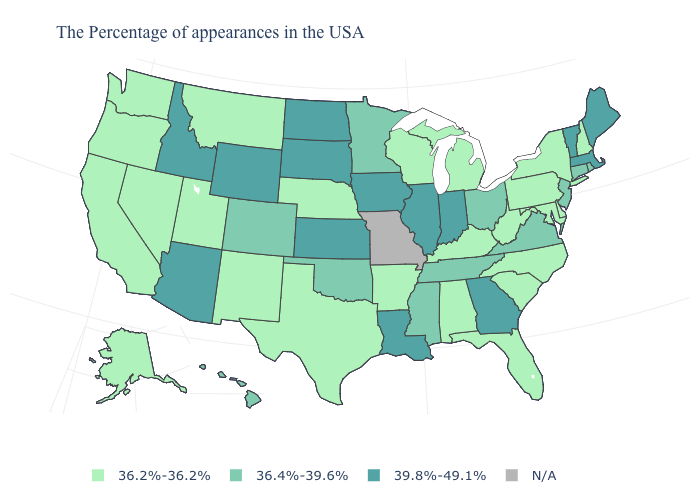Does the map have missing data?
Keep it brief. Yes. What is the highest value in the USA?
Short answer required. 39.8%-49.1%. Name the states that have a value in the range 36.4%-39.6%?
Concise answer only. Rhode Island, Connecticut, New Jersey, Virginia, Ohio, Tennessee, Mississippi, Minnesota, Oklahoma, Colorado, Hawaii. Does Indiana have the lowest value in the MidWest?
Answer briefly. No. Name the states that have a value in the range 36.4%-39.6%?
Give a very brief answer. Rhode Island, Connecticut, New Jersey, Virginia, Ohio, Tennessee, Mississippi, Minnesota, Oklahoma, Colorado, Hawaii. Which states hav the highest value in the South?
Write a very short answer. Georgia, Louisiana. Name the states that have a value in the range 36.4%-39.6%?
Quick response, please. Rhode Island, Connecticut, New Jersey, Virginia, Ohio, Tennessee, Mississippi, Minnesota, Oklahoma, Colorado, Hawaii. What is the highest value in states that border South Dakota?
Concise answer only. 39.8%-49.1%. Among the states that border Virginia , does West Virginia have the highest value?
Quick response, please. No. What is the highest value in the USA?
Answer briefly. 39.8%-49.1%. Which states have the lowest value in the USA?
Give a very brief answer. New Hampshire, New York, Delaware, Maryland, Pennsylvania, North Carolina, South Carolina, West Virginia, Florida, Michigan, Kentucky, Alabama, Wisconsin, Arkansas, Nebraska, Texas, New Mexico, Utah, Montana, Nevada, California, Washington, Oregon, Alaska. Does Pennsylvania have the lowest value in the Northeast?
Write a very short answer. Yes. Which states have the lowest value in the USA?
Concise answer only. New Hampshire, New York, Delaware, Maryland, Pennsylvania, North Carolina, South Carolina, West Virginia, Florida, Michigan, Kentucky, Alabama, Wisconsin, Arkansas, Nebraska, Texas, New Mexico, Utah, Montana, Nevada, California, Washington, Oregon, Alaska. Name the states that have a value in the range 39.8%-49.1%?
Be succinct. Maine, Massachusetts, Vermont, Georgia, Indiana, Illinois, Louisiana, Iowa, Kansas, South Dakota, North Dakota, Wyoming, Arizona, Idaho. 